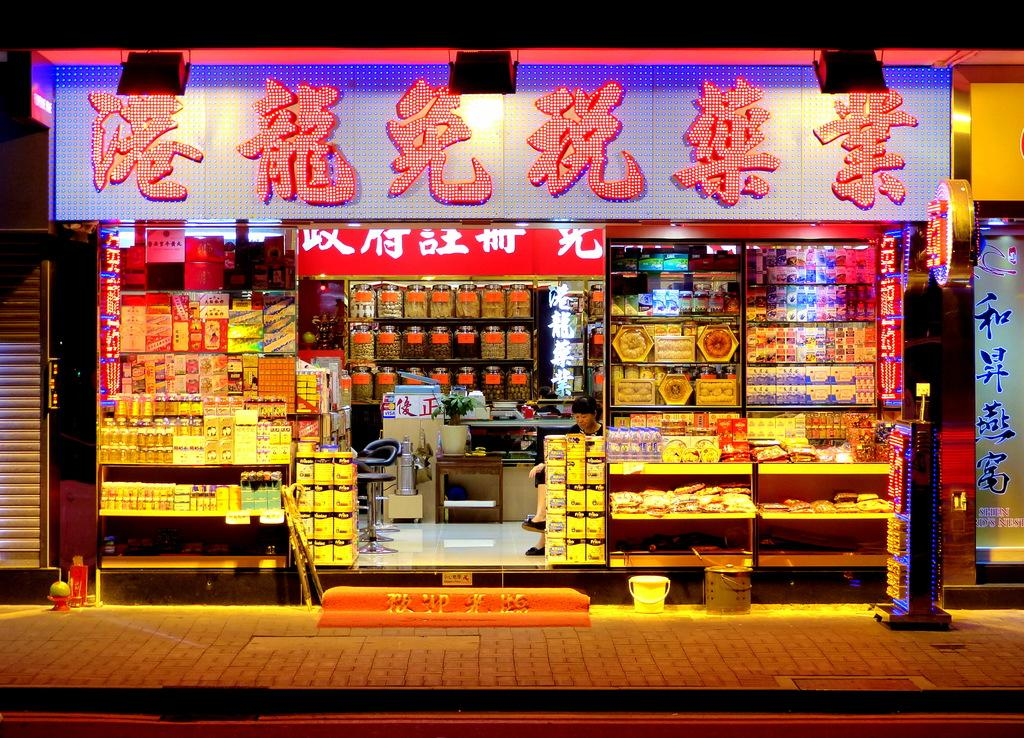What type of establishment is depicted in the image? There is a shop in the image. What can be found inside the shop? There are products in the shop. Is there anyone present in the shop? Yes, there is a person sitting in the shop. What is visible outside the shop? There is a path visible in the image. What type of bear can be seen holding a copper pot in the image? There is no bear or copper pot present in the image; it features a shop with products and a person sitting inside. 